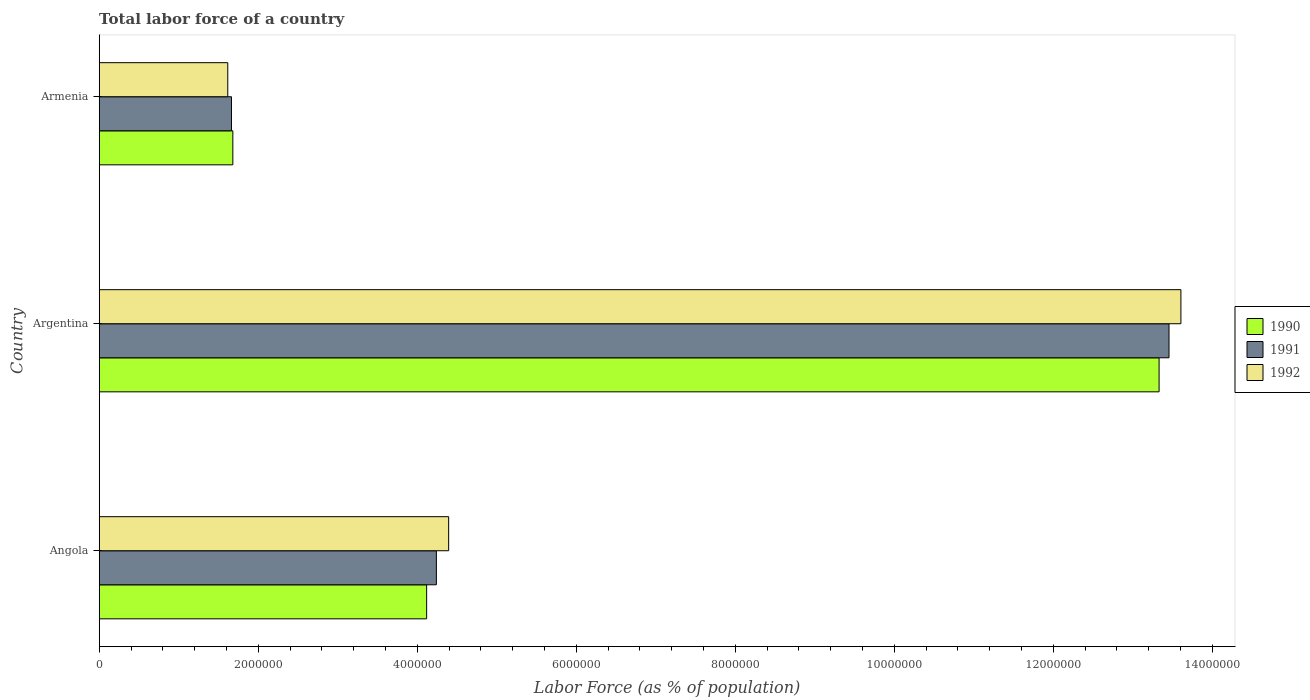How many groups of bars are there?
Your answer should be very brief. 3. Are the number of bars on each tick of the Y-axis equal?
Provide a short and direct response. Yes. How many bars are there on the 1st tick from the top?
Your answer should be very brief. 3. What is the label of the 3rd group of bars from the top?
Your answer should be compact. Angola. What is the percentage of labor force in 1990 in Argentina?
Provide a succinct answer. 1.33e+07. Across all countries, what is the maximum percentage of labor force in 1992?
Offer a terse response. 1.36e+07. Across all countries, what is the minimum percentage of labor force in 1991?
Ensure brevity in your answer.  1.66e+06. In which country was the percentage of labor force in 1991 minimum?
Provide a succinct answer. Armenia. What is the total percentage of labor force in 1992 in the graph?
Ensure brevity in your answer.  1.96e+07. What is the difference between the percentage of labor force in 1990 in Angola and that in Armenia?
Provide a succinct answer. 2.44e+06. What is the difference between the percentage of labor force in 1992 in Argentina and the percentage of labor force in 1990 in Armenia?
Make the answer very short. 1.19e+07. What is the average percentage of labor force in 1992 per country?
Provide a succinct answer. 6.54e+06. What is the difference between the percentage of labor force in 1990 and percentage of labor force in 1991 in Armenia?
Your response must be concise. 1.74e+04. What is the ratio of the percentage of labor force in 1991 in Angola to that in Armenia?
Provide a succinct answer. 2.55. Is the difference between the percentage of labor force in 1990 in Angola and Argentina greater than the difference between the percentage of labor force in 1991 in Angola and Argentina?
Provide a short and direct response. Yes. What is the difference between the highest and the second highest percentage of labor force in 1990?
Provide a short and direct response. 9.21e+06. What is the difference between the highest and the lowest percentage of labor force in 1990?
Offer a very short reply. 1.17e+07. In how many countries, is the percentage of labor force in 1992 greater than the average percentage of labor force in 1992 taken over all countries?
Provide a succinct answer. 1. What does the 3rd bar from the bottom in Angola represents?
Your response must be concise. 1992. Is it the case that in every country, the sum of the percentage of labor force in 1991 and percentage of labor force in 1990 is greater than the percentage of labor force in 1992?
Offer a terse response. Yes. How many bars are there?
Your response must be concise. 9. Are all the bars in the graph horizontal?
Your response must be concise. Yes. Are the values on the major ticks of X-axis written in scientific E-notation?
Your answer should be very brief. No. Does the graph contain grids?
Offer a terse response. No. How many legend labels are there?
Make the answer very short. 3. How are the legend labels stacked?
Offer a very short reply. Vertical. What is the title of the graph?
Ensure brevity in your answer.  Total labor force of a country. Does "1996" appear as one of the legend labels in the graph?
Provide a short and direct response. No. What is the label or title of the X-axis?
Offer a very short reply. Labor Force (as % of population). What is the label or title of the Y-axis?
Offer a very short reply. Country. What is the Labor Force (as % of population) of 1990 in Angola?
Keep it short and to the point. 4.12e+06. What is the Labor Force (as % of population) of 1991 in Angola?
Your response must be concise. 4.24e+06. What is the Labor Force (as % of population) of 1992 in Angola?
Keep it short and to the point. 4.40e+06. What is the Labor Force (as % of population) of 1990 in Argentina?
Offer a very short reply. 1.33e+07. What is the Labor Force (as % of population) in 1991 in Argentina?
Your response must be concise. 1.35e+07. What is the Labor Force (as % of population) of 1992 in Argentina?
Make the answer very short. 1.36e+07. What is the Labor Force (as % of population) in 1990 in Armenia?
Your answer should be compact. 1.68e+06. What is the Labor Force (as % of population) of 1991 in Armenia?
Provide a short and direct response. 1.66e+06. What is the Labor Force (as % of population) of 1992 in Armenia?
Make the answer very short. 1.62e+06. Across all countries, what is the maximum Labor Force (as % of population) in 1990?
Make the answer very short. 1.33e+07. Across all countries, what is the maximum Labor Force (as % of population) in 1991?
Offer a terse response. 1.35e+07. Across all countries, what is the maximum Labor Force (as % of population) of 1992?
Offer a very short reply. 1.36e+07. Across all countries, what is the minimum Labor Force (as % of population) of 1990?
Make the answer very short. 1.68e+06. Across all countries, what is the minimum Labor Force (as % of population) of 1991?
Your answer should be very brief. 1.66e+06. Across all countries, what is the minimum Labor Force (as % of population) in 1992?
Give a very brief answer. 1.62e+06. What is the total Labor Force (as % of population) of 1990 in the graph?
Make the answer very short. 1.91e+07. What is the total Labor Force (as % of population) in 1991 in the graph?
Provide a short and direct response. 1.94e+07. What is the total Labor Force (as % of population) of 1992 in the graph?
Give a very brief answer. 1.96e+07. What is the difference between the Labor Force (as % of population) of 1990 in Angola and that in Argentina?
Provide a succinct answer. -9.21e+06. What is the difference between the Labor Force (as % of population) in 1991 in Angola and that in Argentina?
Offer a terse response. -9.21e+06. What is the difference between the Labor Force (as % of population) of 1992 in Angola and that in Argentina?
Provide a short and direct response. -9.21e+06. What is the difference between the Labor Force (as % of population) of 1990 in Angola and that in Armenia?
Make the answer very short. 2.44e+06. What is the difference between the Labor Force (as % of population) in 1991 in Angola and that in Armenia?
Offer a very short reply. 2.58e+06. What is the difference between the Labor Force (as % of population) in 1992 in Angola and that in Armenia?
Provide a short and direct response. 2.78e+06. What is the difference between the Labor Force (as % of population) of 1990 in Argentina and that in Armenia?
Give a very brief answer. 1.17e+07. What is the difference between the Labor Force (as % of population) in 1991 in Argentina and that in Armenia?
Make the answer very short. 1.18e+07. What is the difference between the Labor Force (as % of population) of 1992 in Argentina and that in Armenia?
Provide a succinct answer. 1.20e+07. What is the difference between the Labor Force (as % of population) of 1990 in Angola and the Labor Force (as % of population) of 1991 in Argentina?
Keep it short and to the point. -9.34e+06. What is the difference between the Labor Force (as % of population) in 1990 in Angola and the Labor Force (as % of population) in 1992 in Argentina?
Offer a very short reply. -9.49e+06. What is the difference between the Labor Force (as % of population) in 1991 in Angola and the Labor Force (as % of population) in 1992 in Argentina?
Your response must be concise. -9.36e+06. What is the difference between the Labor Force (as % of population) of 1990 in Angola and the Labor Force (as % of population) of 1991 in Armenia?
Your answer should be compact. 2.45e+06. What is the difference between the Labor Force (as % of population) of 1990 in Angola and the Labor Force (as % of population) of 1992 in Armenia?
Your answer should be very brief. 2.50e+06. What is the difference between the Labor Force (as % of population) of 1991 in Angola and the Labor Force (as % of population) of 1992 in Armenia?
Give a very brief answer. 2.62e+06. What is the difference between the Labor Force (as % of population) of 1990 in Argentina and the Labor Force (as % of population) of 1991 in Armenia?
Your answer should be compact. 1.17e+07. What is the difference between the Labor Force (as % of population) of 1990 in Argentina and the Labor Force (as % of population) of 1992 in Armenia?
Provide a succinct answer. 1.17e+07. What is the difference between the Labor Force (as % of population) of 1991 in Argentina and the Labor Force (as % of population) of 1992 in Armenia?
Offer a terse response. 1.18e+07. What is the average Labor Force (as % of population) of 1990 per country?
Your response must be concise. 6.38e+06. What is the average Labor Force (as % of population) of 1991 per country?
Ensure brevity in your answer.  6.45e+06. What is the average Labor Force (as % of population) of 1992 per country?
Your answer should be compact. 6.54e+06. What is the difference between the Labor Force (as % of population) of 1990 and Labor Force (as % of population) of 1991 in Angola?
Offer a very short reply. -1.22e+05. What is the difference between the Labor Force (as % of population) of 1990 and Labor Force (as % of population) of 1992 in Angola?
Your answer should be compact. -2.77e+05. What is the difference between the Labor Force (as % of population) of 1991 and Labor Force (as % of population) of 1992 in Angola?
Give a very brief answer. -1.55e+05. What is the difference between the Labor Force (as % of population) of 1990 and Labor Force (as % of population) of 1991 in Argentina?
Your answer should be very brief. -1.25e+05. What is the difference between the Labor Force (as % of population) of 1990 and Labor Force (as % of population) of 1992 in Argentina?
Make the answer very short. -2.74e+05. What is the difference between the Labor Force (as % of population) in 1991 and Labor Force (as % of population) in 1992 in Argentina?
Your answer should be compact. -1.50e+05. What is the difference between the Labor Force (as % of population) in 1990 and Labor Force (as % of population) in 1991 in Armenia?
Your answer should be very brief. 1.74e+04. What is the difference between the Labor Force (as % of population) in 1990 and Labor Force (as % of population) in 1992 in Armenia?
Provide a succinct answer. 6.37e+04. What is the difference between the Labor Force (as % of population) in 1991 and Labor Force (as % of population) in 1992 in Armenia?
Give a very brief answer. 4.64e+04. What is the ratio of the Labor Force (as % of population) of 1990 in Angola to that in Argentina?
Provide a short and direct response. 0.31. What is the ratio of the Labor Force (as % of population) in 1991 in Angola to that in Argentina?
Keep it short and to the point. 0.32. What is the ratio of the Labor Force (as % of population) of 1992 in Angola to that in Argentina?
Give a very brief answer. 0.32. What is the ratio of the Labor Force (as % of population) of 1990 in Angola to that in Armenia?
Your answer should be very brief. 2.45. What is the ratio of the Labor Force (as % of population) in 1991 in Angola to that in Armenia?
Keep it short and to the point. 2.55. What is the ratio of the Labor Force (as % of population) of 1992 in Angola to that in Armenia?
Provide a succinct answer. 2.72. What is the ratio of the Labor Force (as % of population) in 1990 in Argentina to that in Armenia?
Your answer should be very brief. 7.93. What is the ratio of the Labor Force (as % of population) of 1991 in Argentina to that in Armenia?
Your answer should be compact. 8.09. What is the ratio of the Labor Force (as % of population) in 1992 in Argentina to that in Armenia?
Your answer should be compact. 8.41. What is the difference between the highest and the second highest Labor Force (as % of population) of 1990?
Provide a succinct answer. 9.21e+06. What is the difference between the highest and the second highest Labor Force (as % of population) of 1991?
Provide a succinct answer. 9.21e+06. What is the difference between the highest and the second highest Labor Force (as % of population) of 1992?
Make the answer very short. 9.21e+06. What is the difference between the highest and the lowest Labor Force (as % of population) of 1990?
Offer a terse response. 1.17e+07. What is the difference between the highest and the lowest Labor Force (as % of population) of 1991?
Provide a short and direct response. 1.18e+07. What is the difference between the highest and the lowest Labor Force (as % of population) of 1992?
Give a very brief answer. 1.20e+07. 